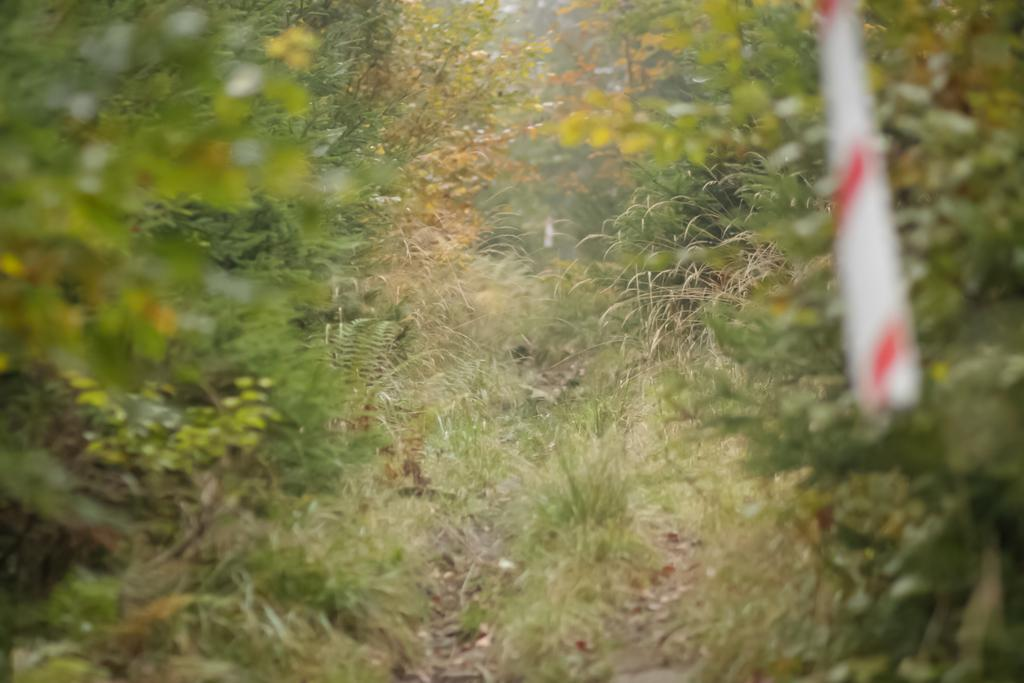What type of vegetation can be seen in the image? There are plants and grass in the image. Can you describe the object located towards the top of the image? Unfortunately, the provided facts do not give enough information to describe the object towards the top of the image. What is the natural setting visible in the image? The natural setting includes plants and grass. What type of table is being used by the dad in the image? There is no table or dad present in the image. What act is the dad performing with the plants in the image? There is no dad or act involving plants present in the image. 